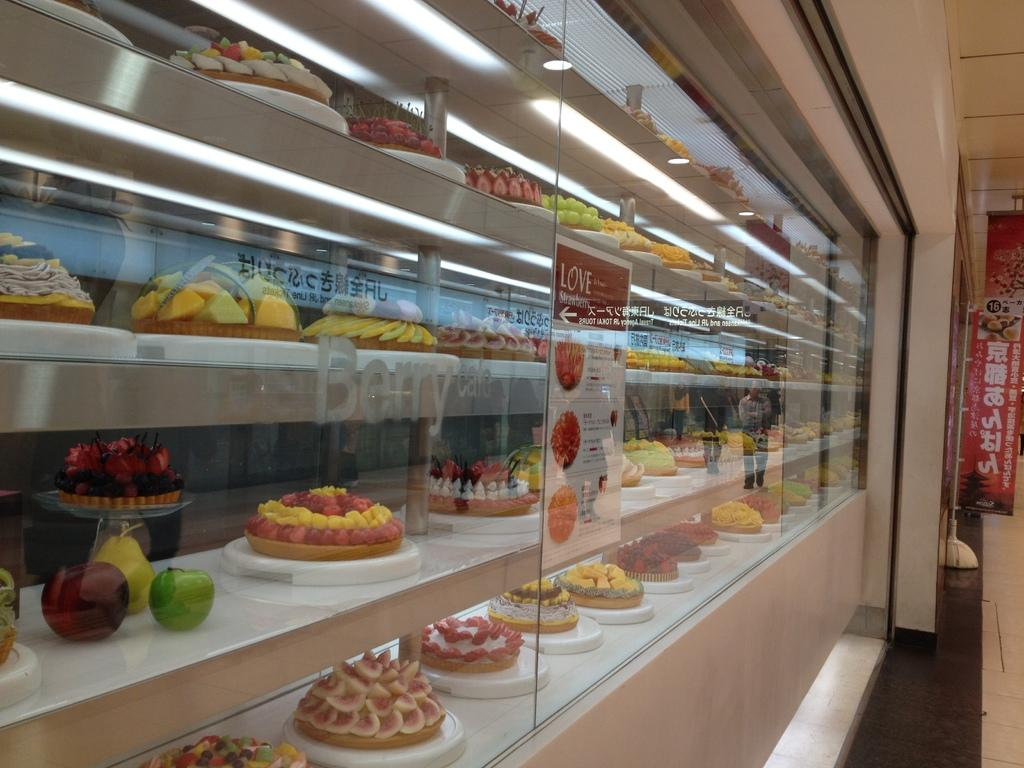Provide a one-sentence caption for the provided image. A bakery case displays a number of different Berry flavored products. 